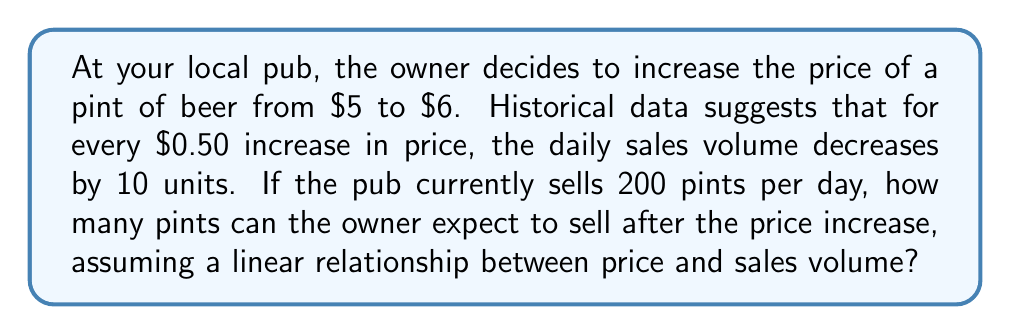Could you help me with this problem? Let's approach this step-by-step:

1. Calculate the price increase:
   $\text{Price increase} = \$6 - \$5 = \$1$

2. Express the price increase in $0.50 increments:
   $\text{Number of } \$0.50 \text{ increments} = \frac{\$1}{\$0.50} = 2$

3. Calculate the expected decrease in sales volume:
   $\text{Decrease per } \$0.50 = 10 \text{ units}$
   $\text{Total decrease} = 2 \times 10 = 20 \text{ units}$

4. Calculate the new expected sales volume:
   $\text{New sales volume} = \text{Current sales} - \text{Total decrease}$
   $\text{New sales volume} = 200 - 20 = 180 \text{ pints}$

Therefore, after the price increase, the pub owner can expect to sell 180 pints per day.
Answer: 180 pints 